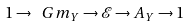Convert formula to latex. <formula><loc_0><loc_0><loc_500><loc_500>1 \to \ G m _ { Y } \to { \mathcal { E } } \to A _ { Y } \to 1</formula> 